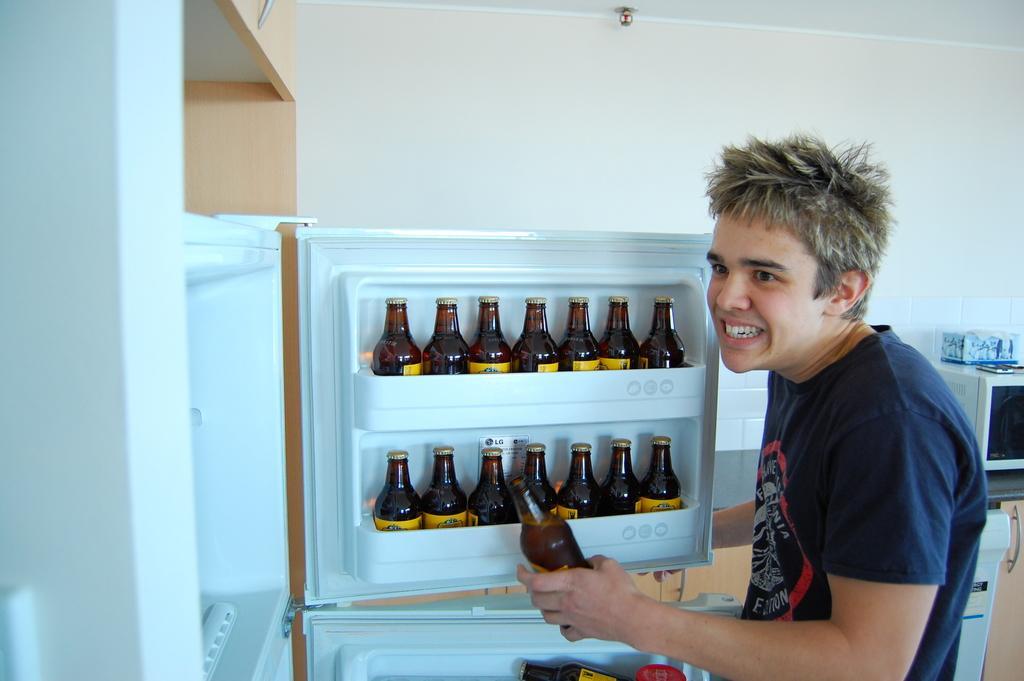Can you describe this image briefly? In this picture I can see there is a man standing here and he is holding a beer bottle in his hand, on to left side there is refrigerator and there are some beer bottles arranged in the fridge and in the backdrop there is a wall and oven. 